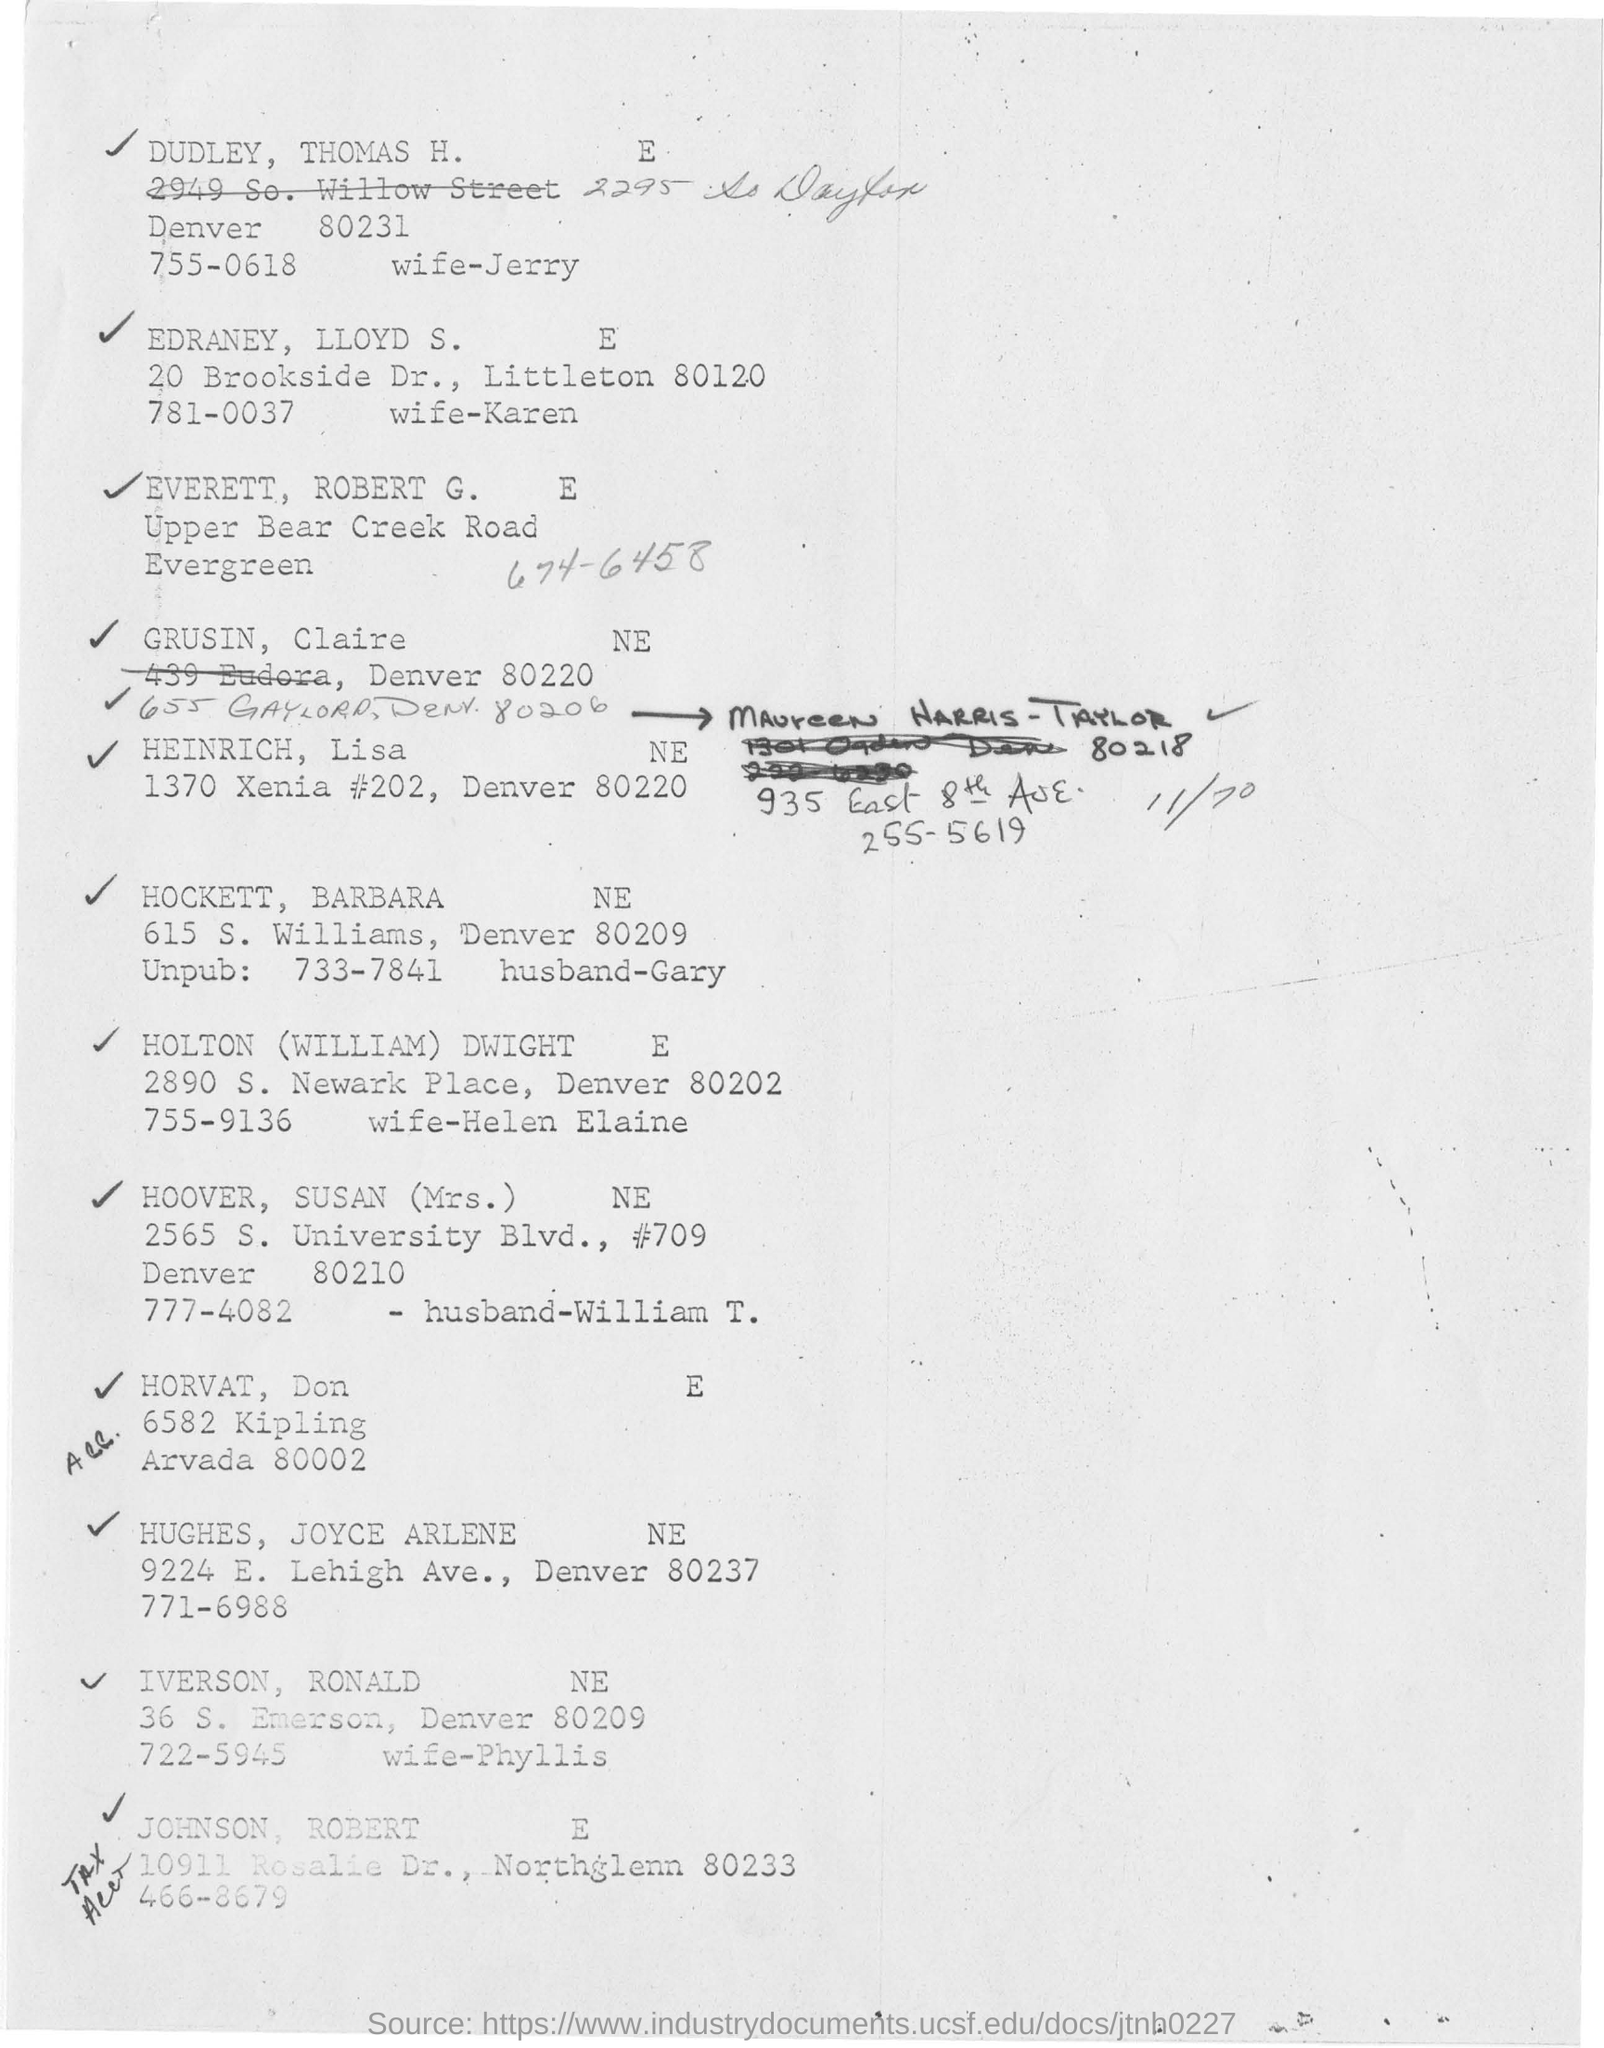Who is husband of jerry ?
Keep it short and to the point. DUDLEY, THOMAS H. Who is the wife of iverson, ronald     ne?
Give a very brief answer. Phyllis. Who is the husband of mrs. hoover,susan    ne?
Your answer should be compact. William T. What is the address of HEINRICH, lisa   NE?
Provide a succinct answer. 1370 Xenia #202, Denver 80220. 